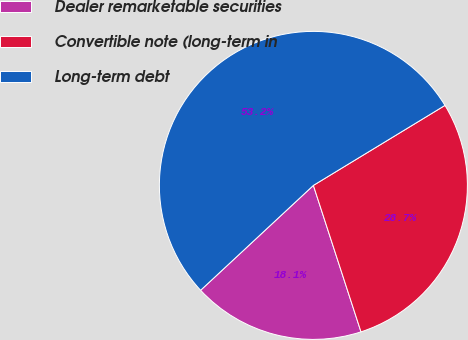Convert chart. <chart><loc_0><loc_0><loc_500><loc_500><pie_chart><fcel>Dealer remarketable securities<fcel>Convertible note (long-term in<fcel>Long-term debt<nl><fcel>18.08%<fcel>28.69%<fcel>53.23%<nl></chart> 